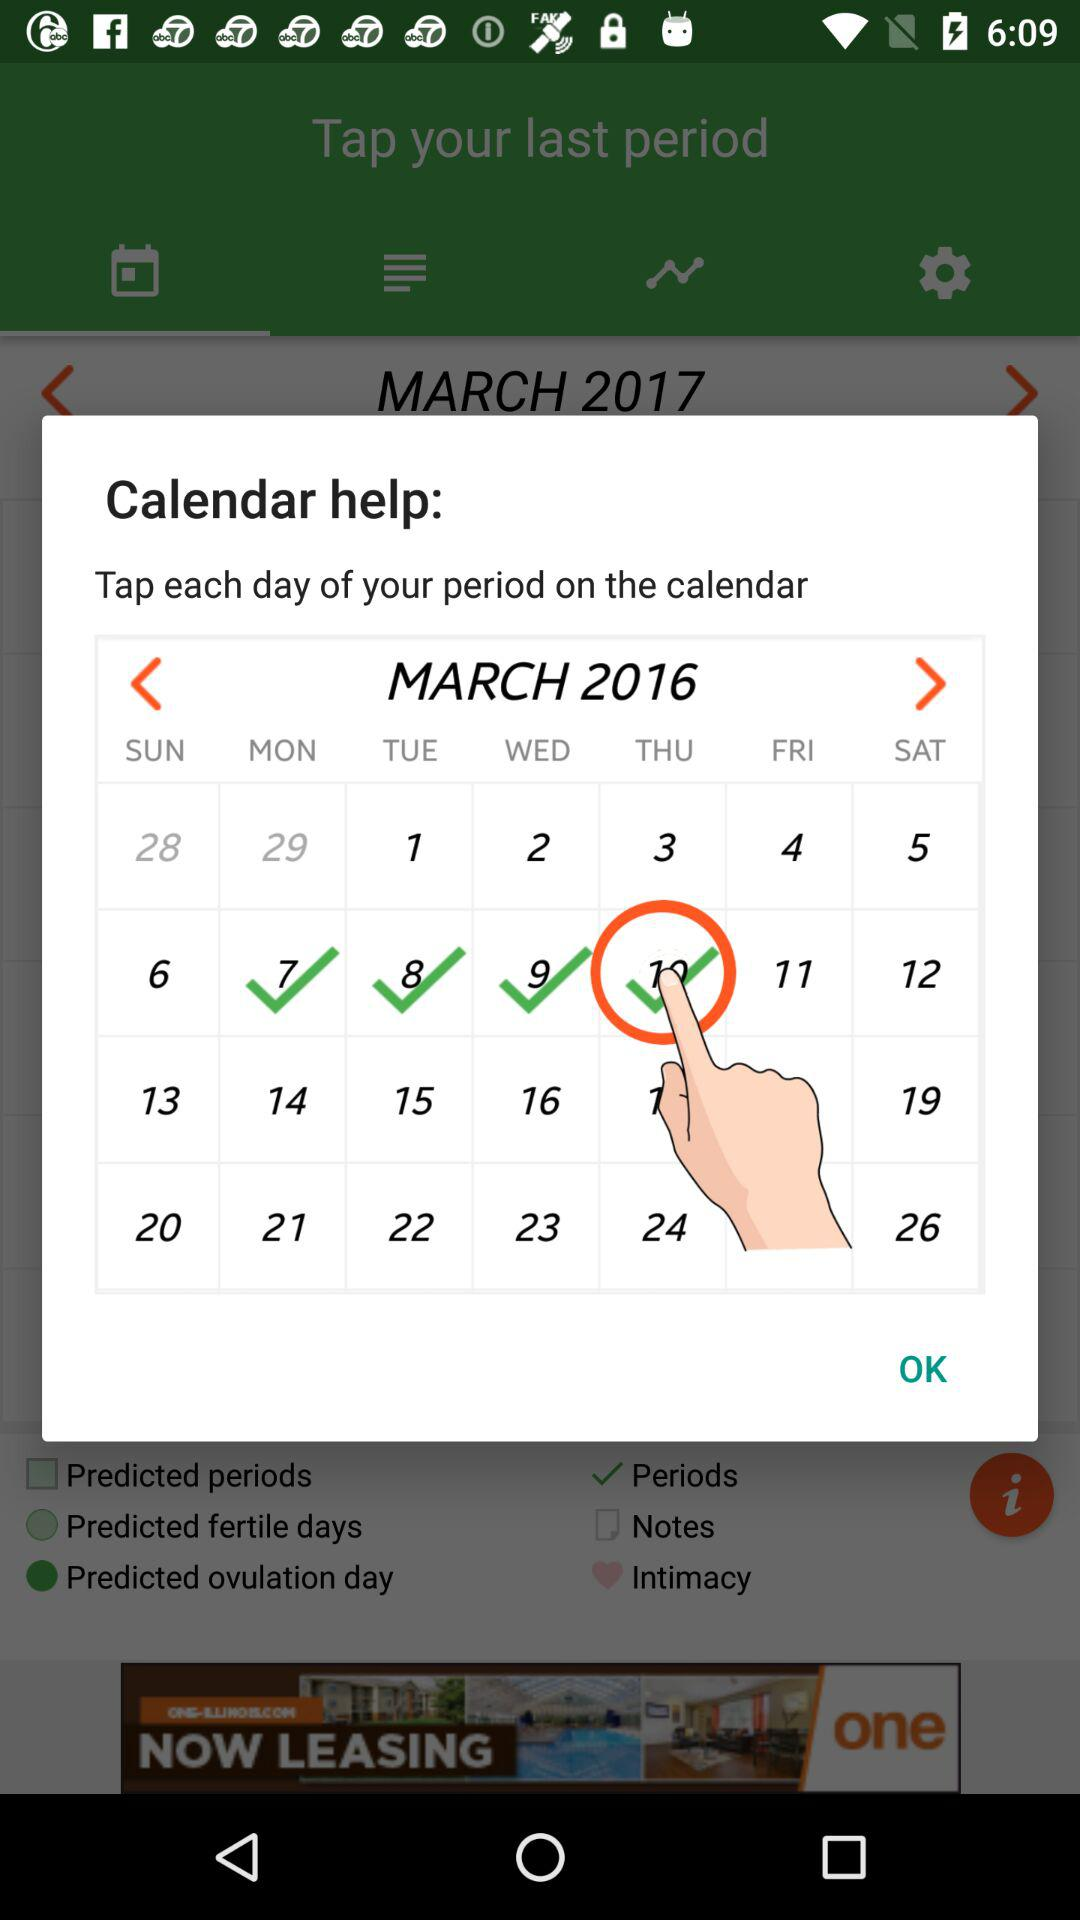Which dates are selected on the calendar? The selected dates are from March 7th, 2016 to March 10th, 2016. 